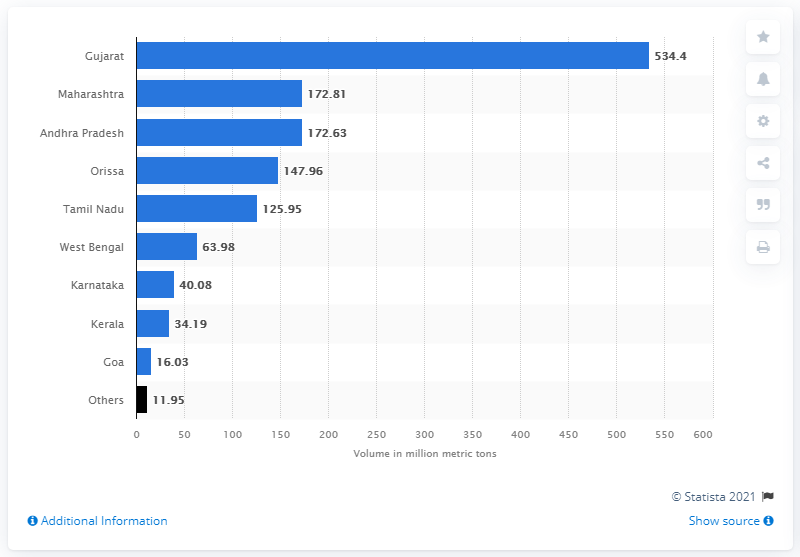Specify some key components in this picture. According to the data provided, the minimum volume of cargo handled at the ports of Gujarat was in Goa. By the end of the fiscal year 2020, the ports of Gujarat had handled a total volume of 534.4 million metric tons of sea cargo traffic. 